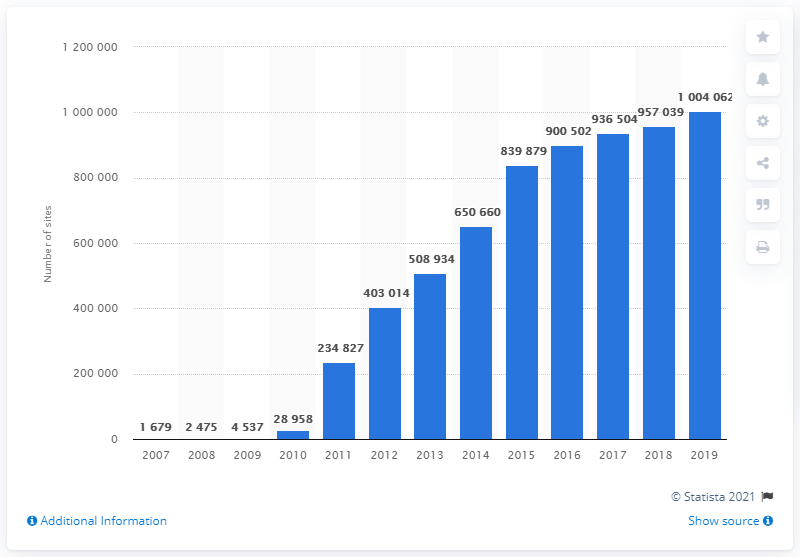Indicate a few pertinent items in this graphic. Commercial distribution of solar photovoltaic systems began in the year 2007. 